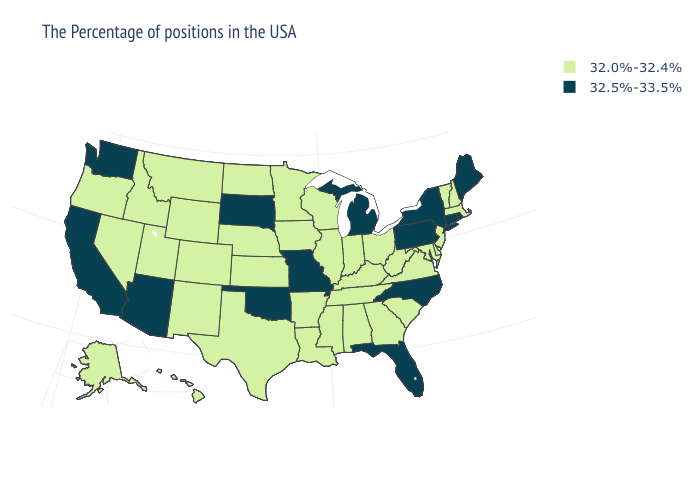Does North Carolina have the highest value in the South?
Concise answer only. Yes. Does North Carolina have the lowest value in the USA?
Give a very brief answer. No. Among the states that border California , which have the lowest value?
Quick response, please. Nevada, Oregon. How many symbols are there in the legend?
Short answer required. 2. Does Wisconsin have the lowest value in the USA?
Short answer required. Yes. What is the highest value in the Northeast ?
Short answer required. 32.5%-33.5%. What is the value of Pennsylvania?
Concise answer only. 32.5%-33.5%. What is the highest value in states that border New Hampshire?
Answer briefly. 32.5%-33.5%. Does Maine have a higher value than Missouri?
Short answer required. No. What is the value of New Hampshire?
Keep it brief. 32.0%-32.4%. Name the states that have a value in the range 32.0%-32.4%?
Short answer required. Massachusetts, New Hampshire, Vermont, New Jersey, Delaware, Maryland, Virginia, South Carolina, West Virginia, Ohio, Georgia, Kentucky, Indiana, Alabama, Tennessee, Wisconsin, Illinois, Mississippi, Louisiana, Arkansas, Minnesota, Iowa, Kansas, Nebraska, Texas, North Dakota, Wyoming, Colorado, New Mexico, Utah, Montana, Idaho, Nevada, Oregon, Alaska, Hawaii. What is the value of Wyoming?
Concise answer only. 32.0%-32.4%. Does Michigan have the highest value in the MidWest?
Keep it brief. Yes. Name the states that have a value in the range 32.0%-32.4%?
Quick response, please. Massachusetts, New Hampshire, Vermont, New Jersey, Delaware, Maryland, Virginia, South Carolina, West Virginia, Ohio, Georgia, Kentucky, Indiana, Alabama, Tennessee, Wisconsin, Illinois, Mississippi, Louisiana, Arkansas, Minnesota, Iowa, Kansas, Nebraska, Texas, North Dakota, Wyoming, Colorado, New Mexico, Utah, Montana, Idaho, Nevada, Oregon, Alaska, Hawaii. Which states have the lowest value in the USA?
Write a very short answer. Massachusetts, New Hampshire, Vermont, New Jersey, Delaware, Maryland, Virginia, South Carolina, West Virginia, Ohio, Georgia, Kentucky, Indiana, Alabama, Tennessee, Wisconsin, Illinois, Mississippi, Louisiana, Arkansas, Minnesota, Iowa, Kansas, Nebraska, Texas, North Dakota, Wyoming, Colorado, New Mexico, Utah, Montana, Idaho, Nevada, Oregon, Alaska, Hawaii. 